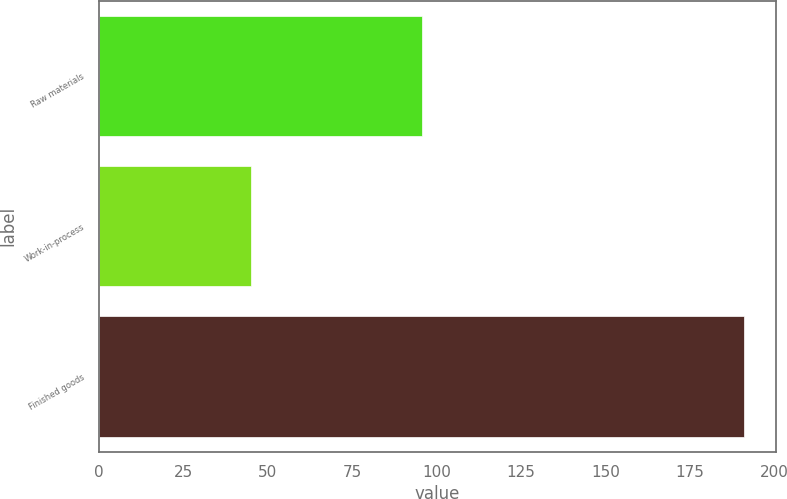<chart> <loc_0><loc_0><loc_500><loc_500><bar_chart><fcel>Raw materials<fcel>Work-in-process<fcel>Finished goods<nl><fcel>95.7<fcel>45<fcel>190.9<nl></chart> 